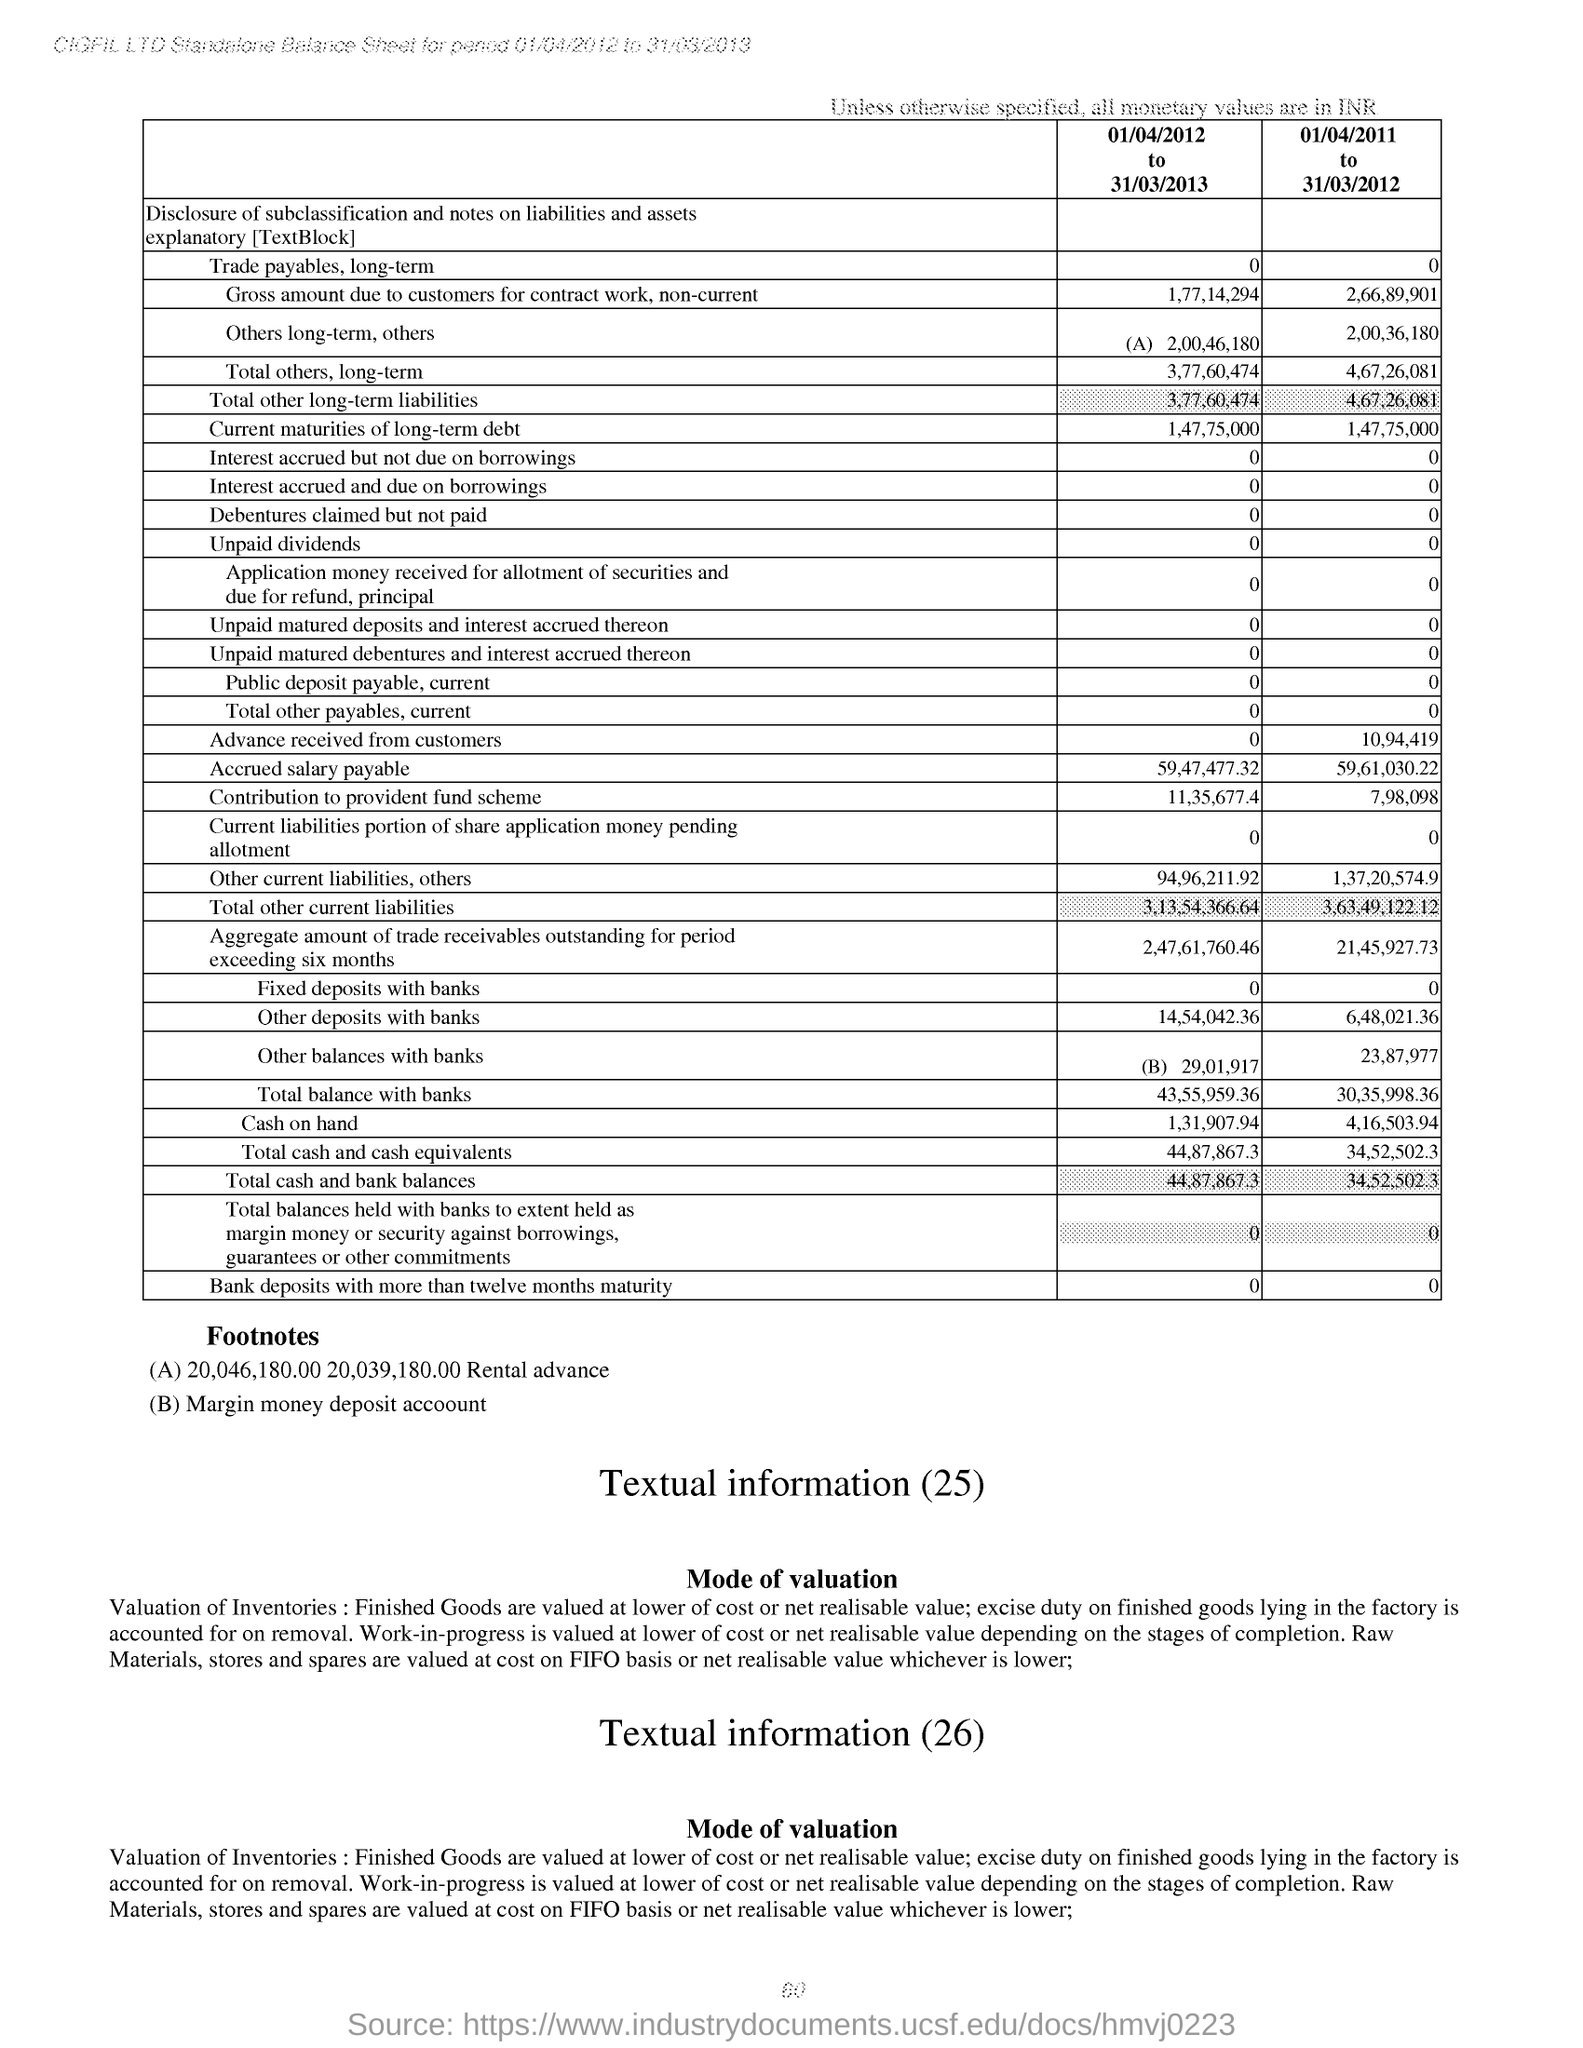Indicate a few pertinent items in this graphic. The value for the "Total others, long-term" category for the period of "01/04/2012 to 31/03/2013" is 3,77,60,474. 